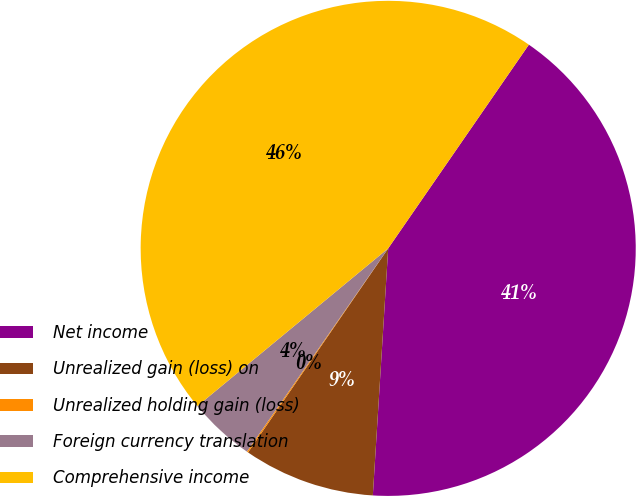Convert chart to OTSL. <chart><loc_0><loc_0><loc_500><loc_500><pie_chart><fcel>Net income<fcel>Unrealized gain (loss) on<fcel>Unrealized holding gain (loss)<fcel>Foreign currency translation<fcel>Comprehensive income<nl><fcel>41.37%<fcel>8.59%<fcel>0.09%<fcel>4.34%<fcel>45.61%<nl></chart> 